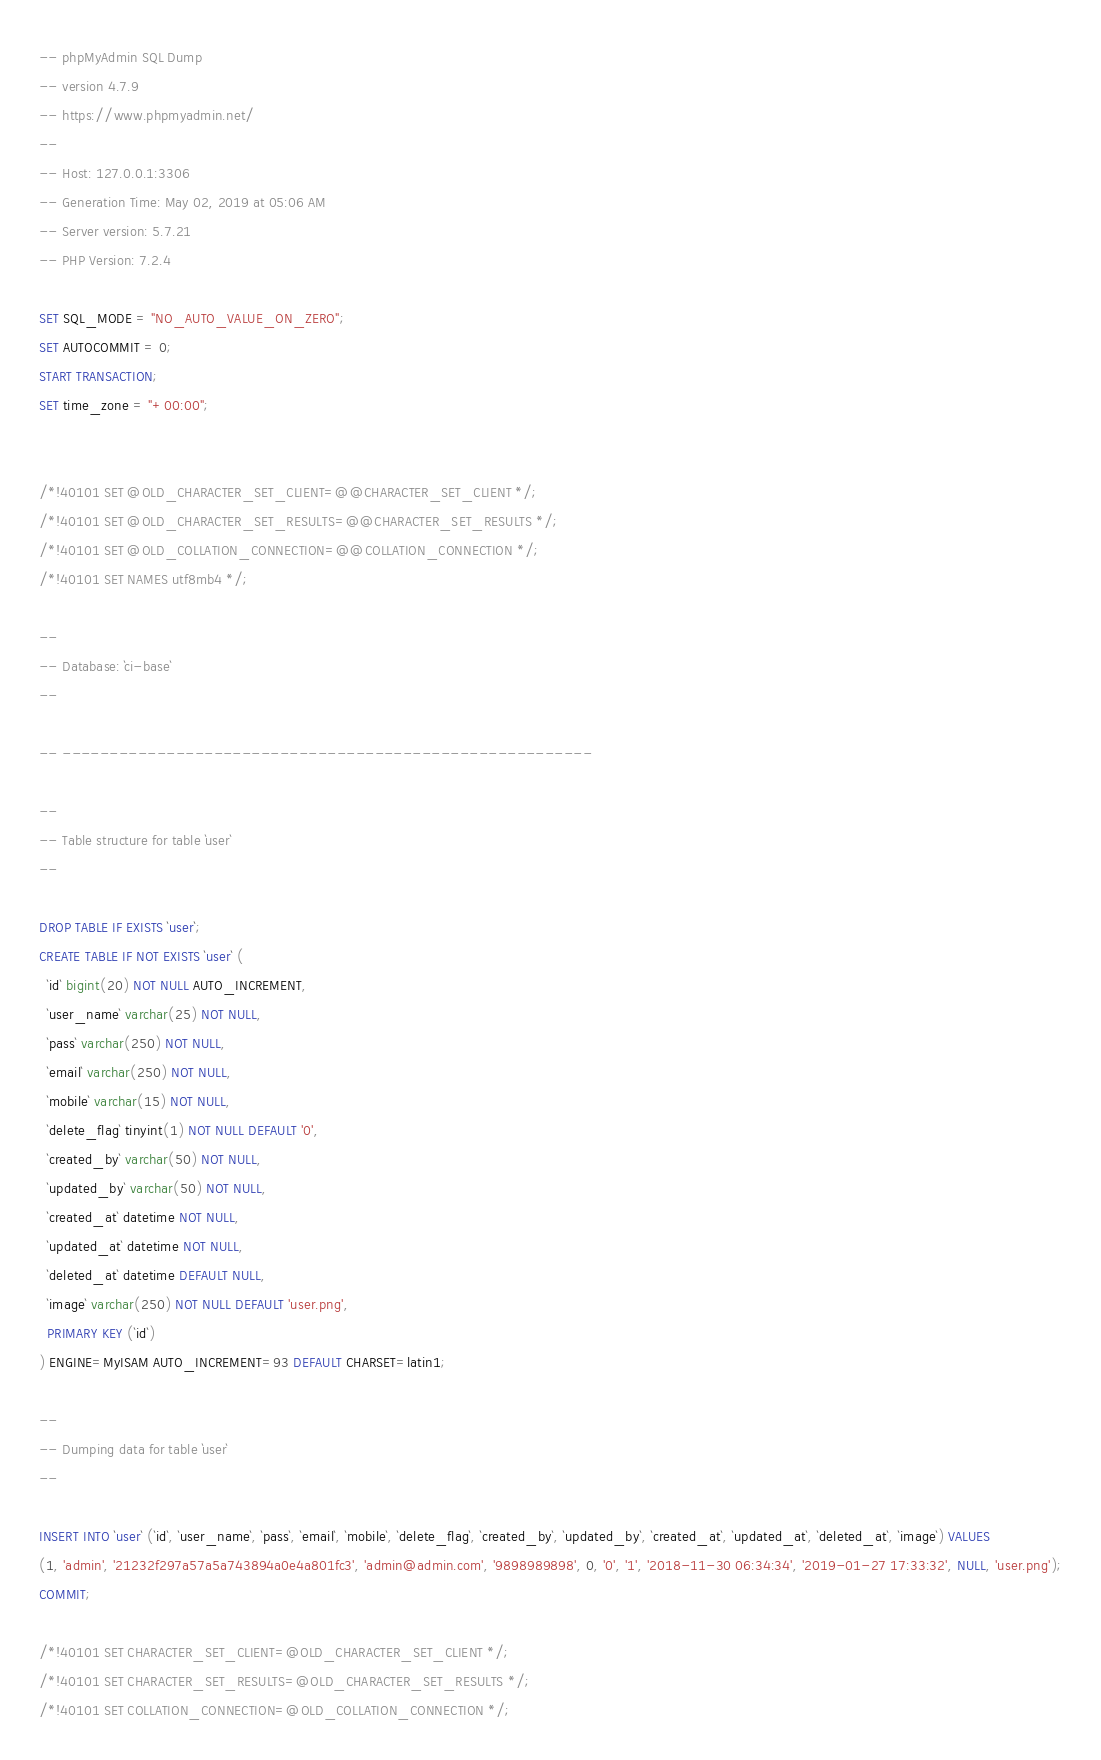Convert code to text. <code><loc_0><loc_0><loc_500><loc_500><_SQL_>-- phpMyAdmin SQL Dump
-- version 4.7.9
-- https://www.phpmyadmin.net/
--
-- Host: 127.0.0.1:3306
-- Generation Time: May 02, 2019 at 05:06 AM
-- Server version: 5.7.21
-- PHP Version: 7.2.4

SET SQL_MODE = "NO_AUTO_VALUE_ON_ZERO";
SET AUTOCOMMIT = 0;
START TRANSACTION;
SET time_zone = "+00:00";


/*!40101 SET @OLD_CHARACTER_SET_CLIENT=@@CHARACTER_SET_CLIENT */;
/*!40101 SET @OLD_CHARACTER_SET_RESULTS=@@CHARACTER_SET_RESULTS */;
/*!40101 SET @OLD_COLLATION_CONNECTION=@@COLLATION_CONNECTION */;
/*!40101 SET NAMES utf8mb4 */;

--
-- Database: `ci-base`
--

-- --------------------------------------------------------

--
-- Table structure for table `user`
--

DROP TABLE IF EXISTS `user`;
CREATE TABLE IF NOT EXISTS `user` (
  `id` bigint(20) NOT NULL AUTO_INCREMENT,
  `user_name` varchar(25) NOT NULL,
  `pass` varchar(250) NOT NULL,
  `email` varchar(250) NOT NULL,
  `mobile` varchar(15) NOT NULL,
  `delete_flag` tinyint(1) NOT NULL DEFAULT '0',
  `created_by` varchar(50) NOT NULL,
  `updated_by` varchar(50) NOT NULL,
  `created_at` datetime NOT NULL,
  `updated_at` datetime NOT NULL,
  `deleted_at` datetime DEFAULT NULL,
  `image` varchar(250) NOT NULL DEFAULT 'user.png',
  PRIMARY KEY (`id`)
) ENGINE=MyISAM AUTO_INCREMENT=93 DEFAULT CHARSET=latin1;

--
-- Dumping data for table `user`
--

INSERT INTO `user` (`id`, `user_name`, `pass`, `email`, `mobile`, `delete_flag`, `created_by`, `updated_by`, `created_at`, `updated_at`, `deleted_at`, `image`) VALUES
(1, 'admin', '21232f297a57a5a743894a0e4a801fc3', 'admin@admin.com', '9898989898', 0, '0', '1', '2018-11-30 06:34:34', '2019-01-27 17:33:32', NULL, 'user.png');
COMMIT;

/*!40101 SET CHARACTER_SET_CLIENT=@OLD_CHARACTER_SET_CLIENT */;
/*!40101 SET CHARACTER_SET_RESULTS=@OLD_CHARACTER_SET_RESULTS */;
/*!40101 SET COLLATION_CONNECTION=@OLD_COLLATION_CONNECTION */;
</code> 